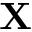Convert formula to latex. <formula><loc_0><loc_0><loc_500><loc_500>X</formula> 